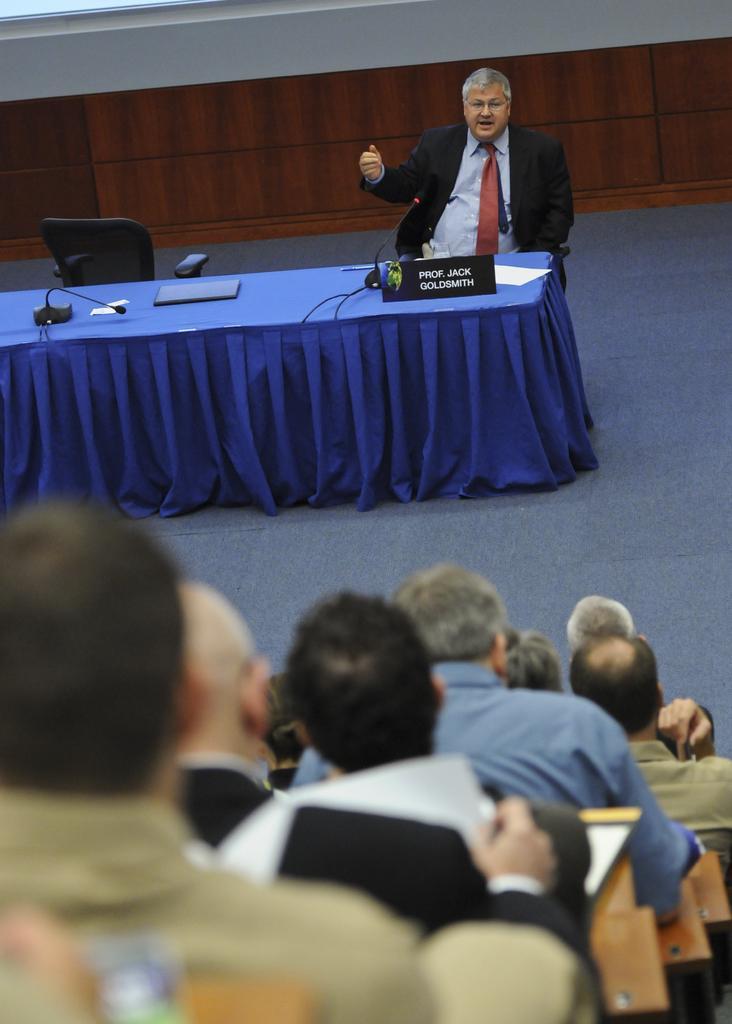In one or two sentences, can you explain what this image depicts? There are many persons sitting. And a person in white and a black coat is sitting on a chair and talking. There is a another chair near to him. In front of him there is a table with a blue cloth. On the table there are mice , name board, paper and a laptop. In the background there is a wall. 